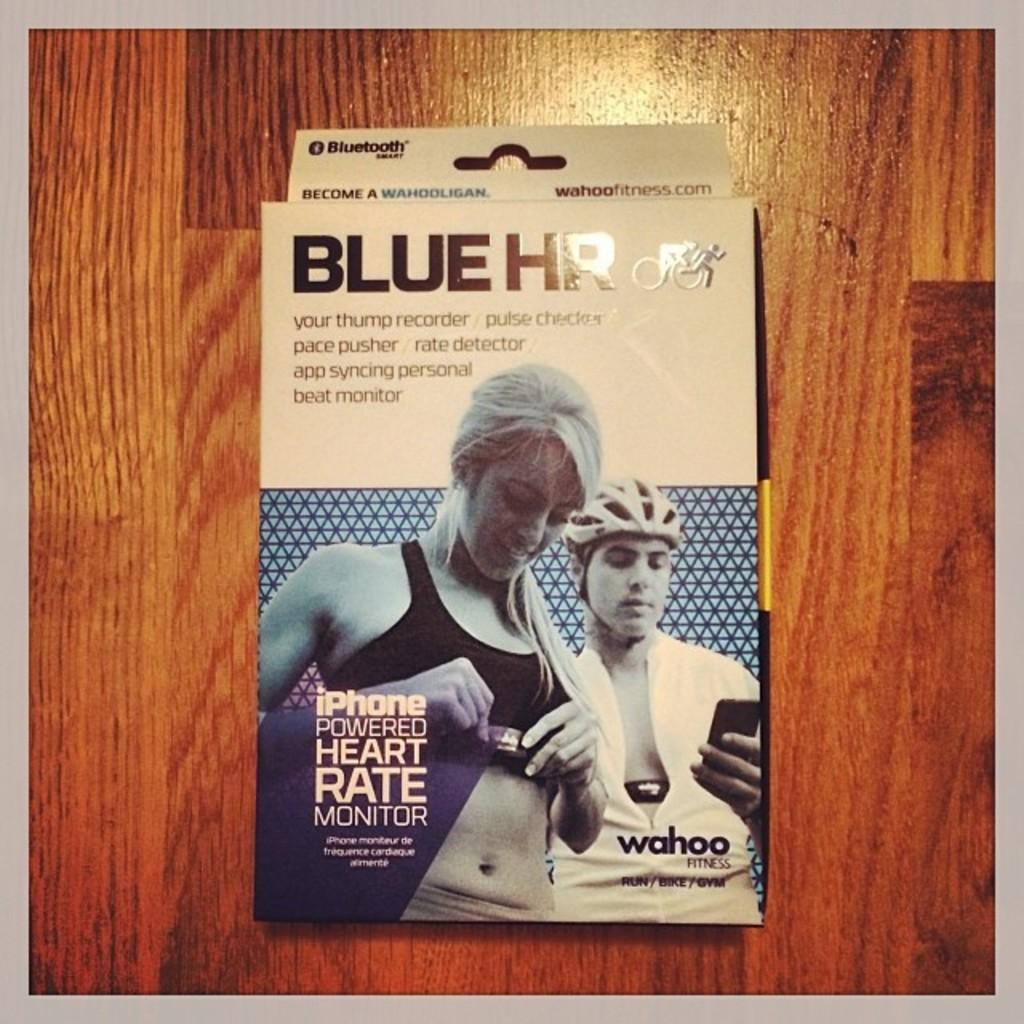Provide a one-sentence caption for the provided image. An iPhone powered heart rate monitor from the brand Blue HR. 